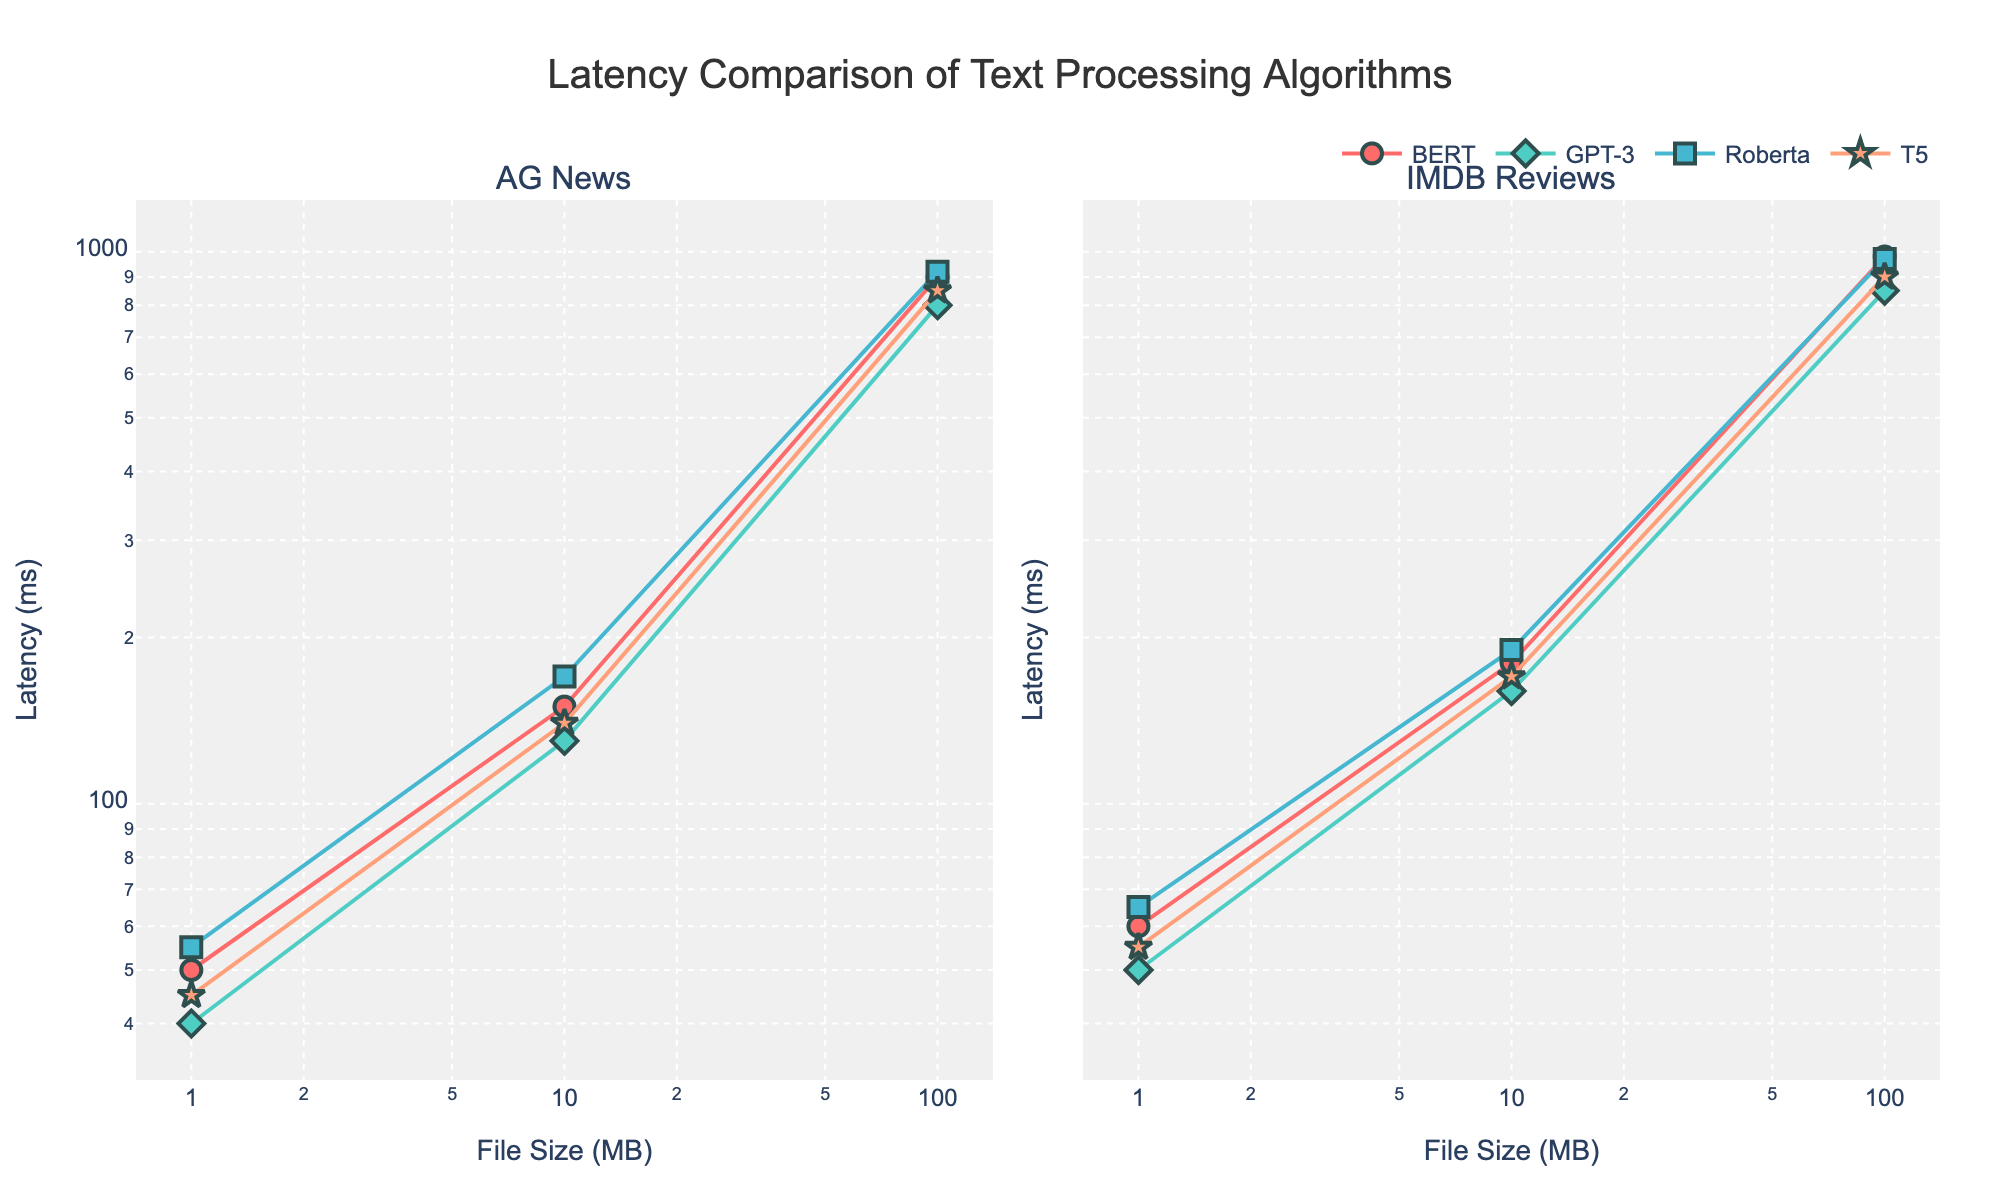What's the title of the plot? The title of the plot is displayed at the top center of the figure. It reads "Latency Comparison of Text Processing Algorithms."
Answer: Latency Comparison of Text Processing Algorithms What is the x-axis and y-axis representing? The x-axis represents the file size in megabytes (MB), and the y-axis represents the latency in milliseconds (ms). Both axes are using a logarithmic scale.
Answer: File Size (MB) and Latency (ms) Which algorithm has the lowest latency for 1 MB file size on AG News? According to the plot on the left for AG News, the algorithm with the lowest latency for a 1 MB file size is GPT-3.
Answer: GPT-3 Which dataset shows higher latency for BERT with a 100 MB file size? By comparing the latency points for BERT on both subplots (AG News on the left and IMDB Reviews on the right), we can see that BERT has higher latency for IMDB Reviews with a 100 MB file size.
Answer: IMDB Reviews What is the difference in latency between GPT-3 and Roberta for a 10 MB file size on IMDB Reviews? On the subplot for IMDB Reviews, the latency for GPT-3 at 10 MB is 160 ms, and for Roberta, it is 190 ms. The difference is 190 ms - 160 ms = 30 ms.
Answer: 30 ms Which algorithm shows the smallest increase in latency when increasing the file size from 10 MB to 100 MB on AG News? By examining the AG News plot and comparing the lines' slopes from 10 MB to 100 MB, we can see that GPT-3 has the smallest increase in latency within this file size range.
Answer: GPT-3 What is the latency for T5 with IMDB Reviews at 1 MB file size? Looking at the right subplot for IMDB Reviews, the latency for T5 with a 1 MB file size is 55 ms.
Answer: 55 ms Which algorithm has the steepest slope for latency versus file size on AG News? By observing the steepness of the lines on the left subplot for AG News, Roberta has the steepest slope indicating the highest rate of increase in latency with increasing file size.
Answer: Roberta Is there any algorithm that has consistently lower latency across all datasets and file sizes? By examining the plots, we can see that GPT-3 generally shows lower latencies across all datasets and file sizes compared to other algorithms.
Answer: GPT-3 What's the average latency of T5 for AG News across all file sizes? The latency values for T5 on AG News across all file sizes are 45 ms, 140 ms, and 850 ms. Adding these gives: 45 + 140 + 850 = 1035 ms. There are 3 data points, so the average is 1035 / 3 = 345 ms.
Answer: 345 ms 